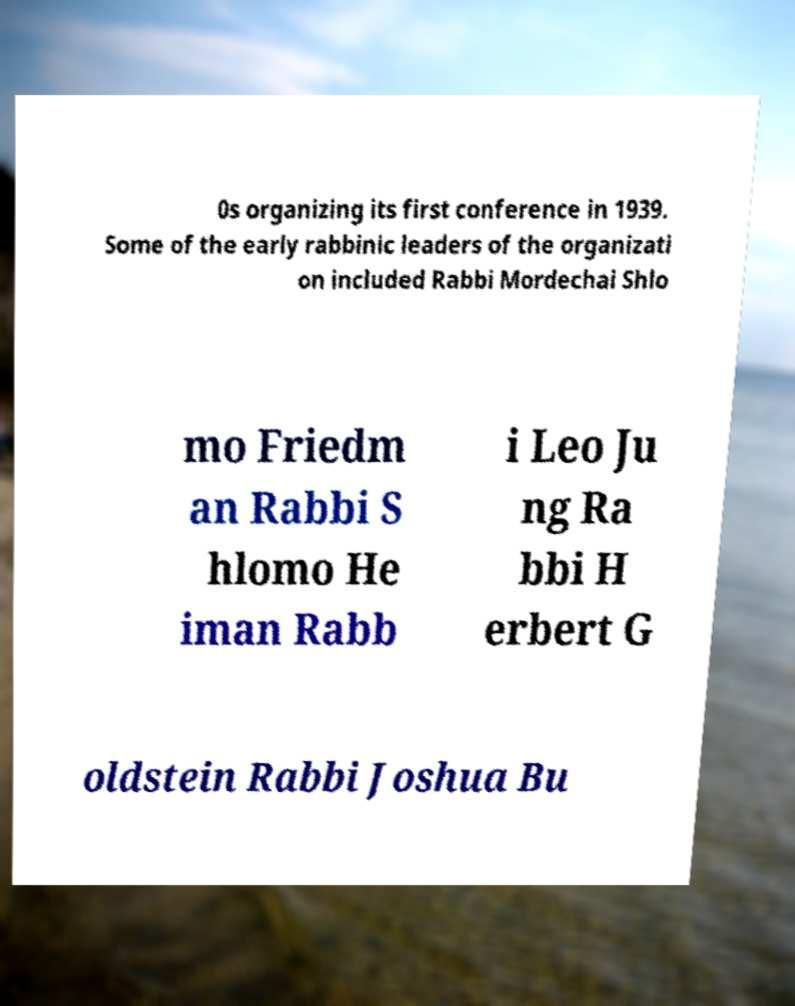Could you assist in decoding the text presented in this image and type it out clearly? 0s organizing its first conference in 1939. Some of the early rabbinic leaders of the organizati on included Rabbi Mordechai Shlo mo Friedm an Rabbi S hlomo He iman Rabb i Leo Ju ng Ra bbi H erbert G oldstein Rabbi Joshua Bu 